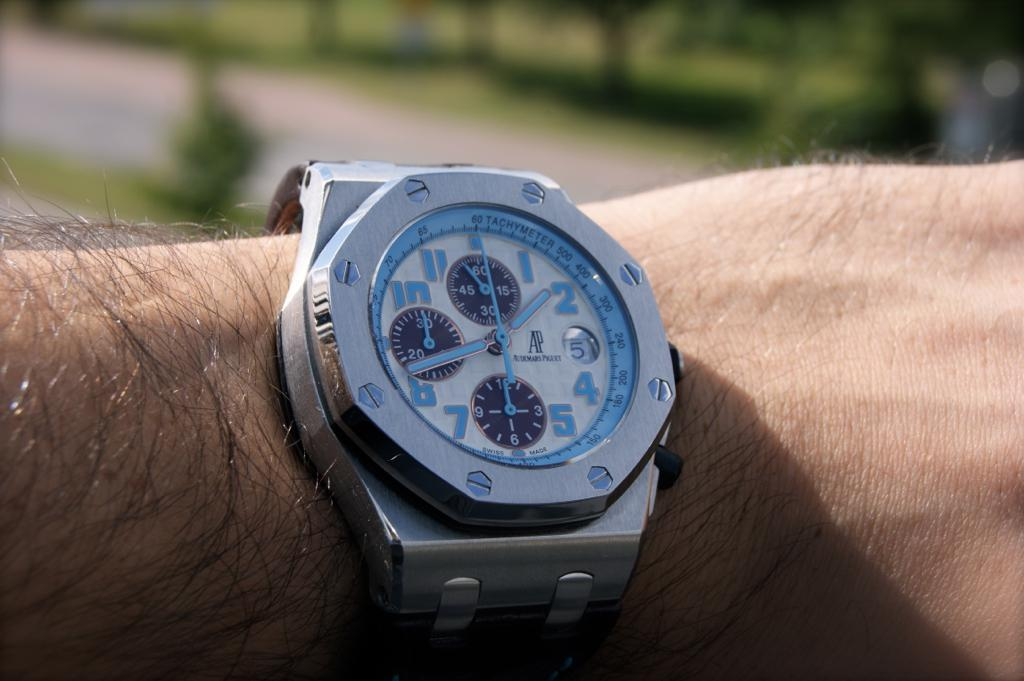<image>
Relay a brief, clear account of the picture shown. A man is wearing a silver watch with the number 5 on it. 